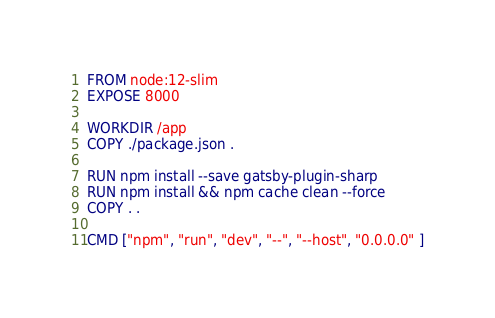Convert code to text. <code><loc_0><loc_0><loc_500><loc_500><_Dockerfile_>FROM node:12-slim
EXPOSE 8000

WORKDIR /app
COPY ./package.json .

RUN npm install --save gatsby-plugin-sharp
RUN npm install && npm cache clean --force
COPY . .

CMD ["npm", "run", "dev", "--", "--host", "0.0.0.0" ]
</code> 